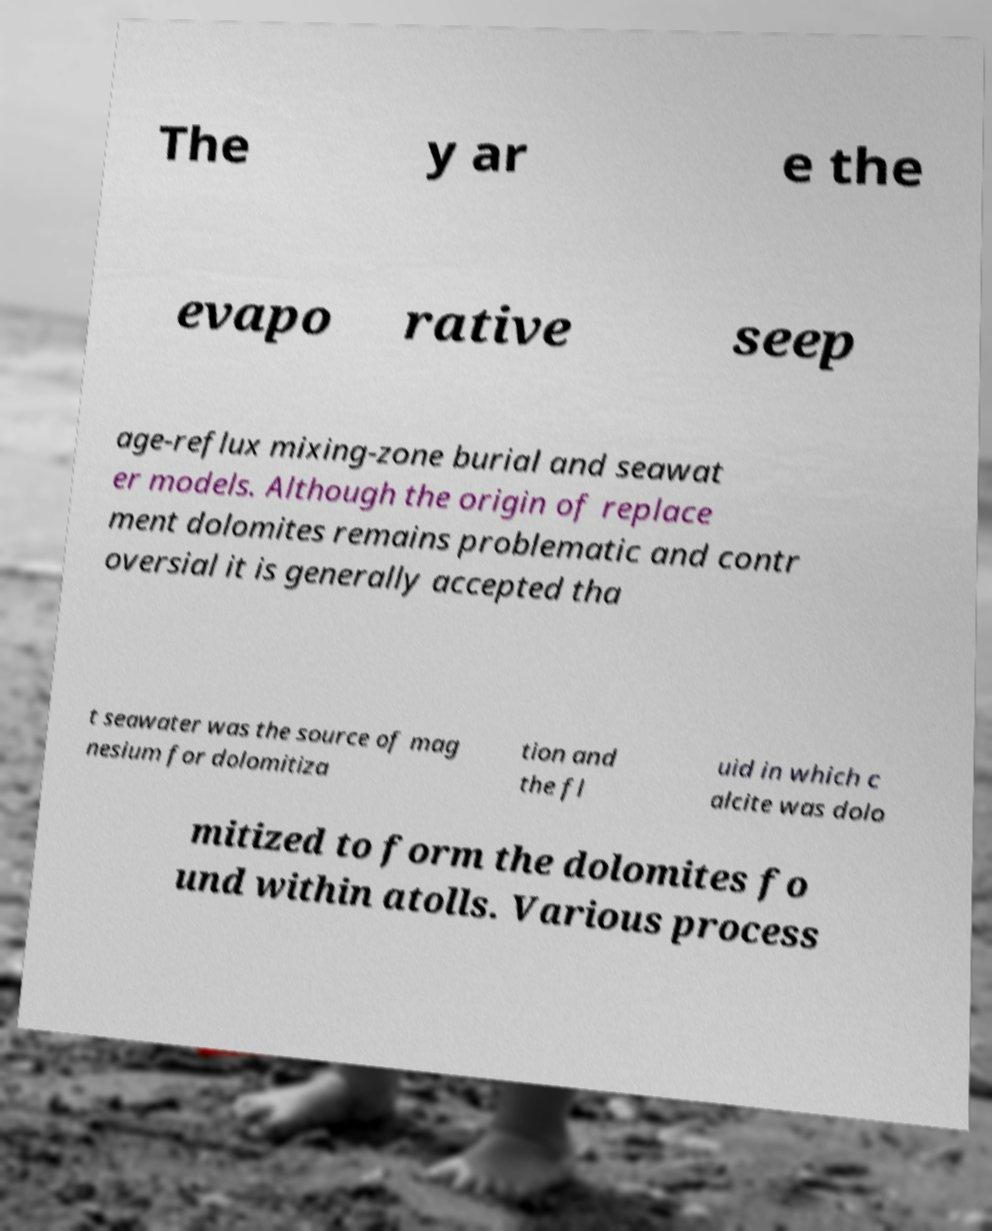What messages or text are displayed in this image? I need them in a readable, typed format. The y ar e the evapo rative seep age-reflux mixing-zone burial and seawat er models. Although the origin of replace ment dolomites remains problematic and contr oversial it is generally accepted tha t seawater was the source of mag nesium for dolomitiza tion and the fl uid in which c alcite was dolo mitized to form the dolomites fo und within atolls. Various process 